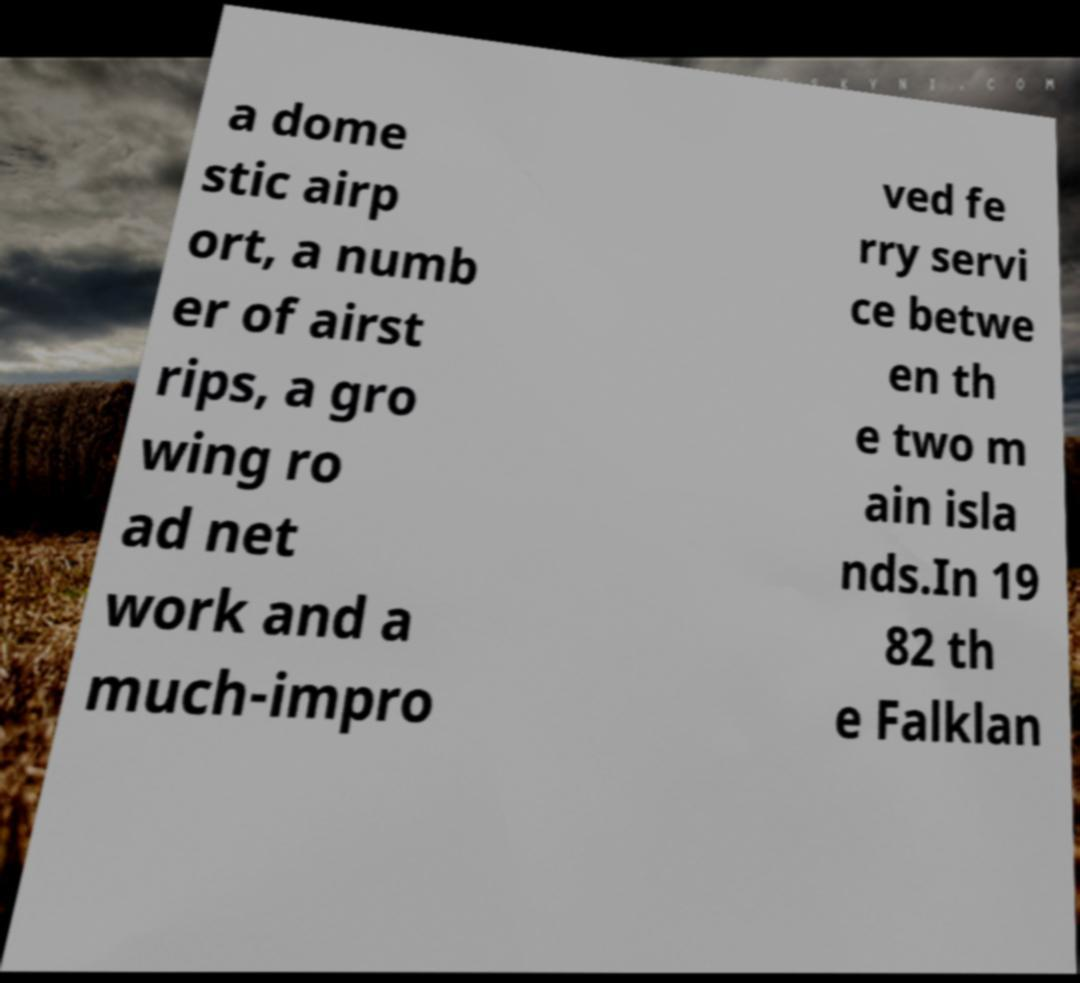For documentation purposes, I need the text within this image transcribed. Could you provide that? a dome stic airp ort, a numb er of airst rips, a gro wing ro ad net work and a much-impro ved fe rry servi ce betwe en th e two m ain isla nds.In 19 82 th e Falklan 